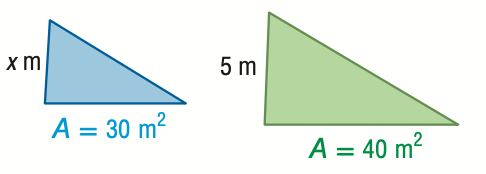Question: For the pair of similar figures, use the given areas to find the scale factor from the blue to the green figure.
Choices:
A. \frac { 3 } { 4 }
B. \frac { \sqrt { 3 } } { 2 }
C. \frac { 2 } { \sqrt { 3 } }
D. \frac { 4 } { 3 }
Answer with the letter. Answer: B 